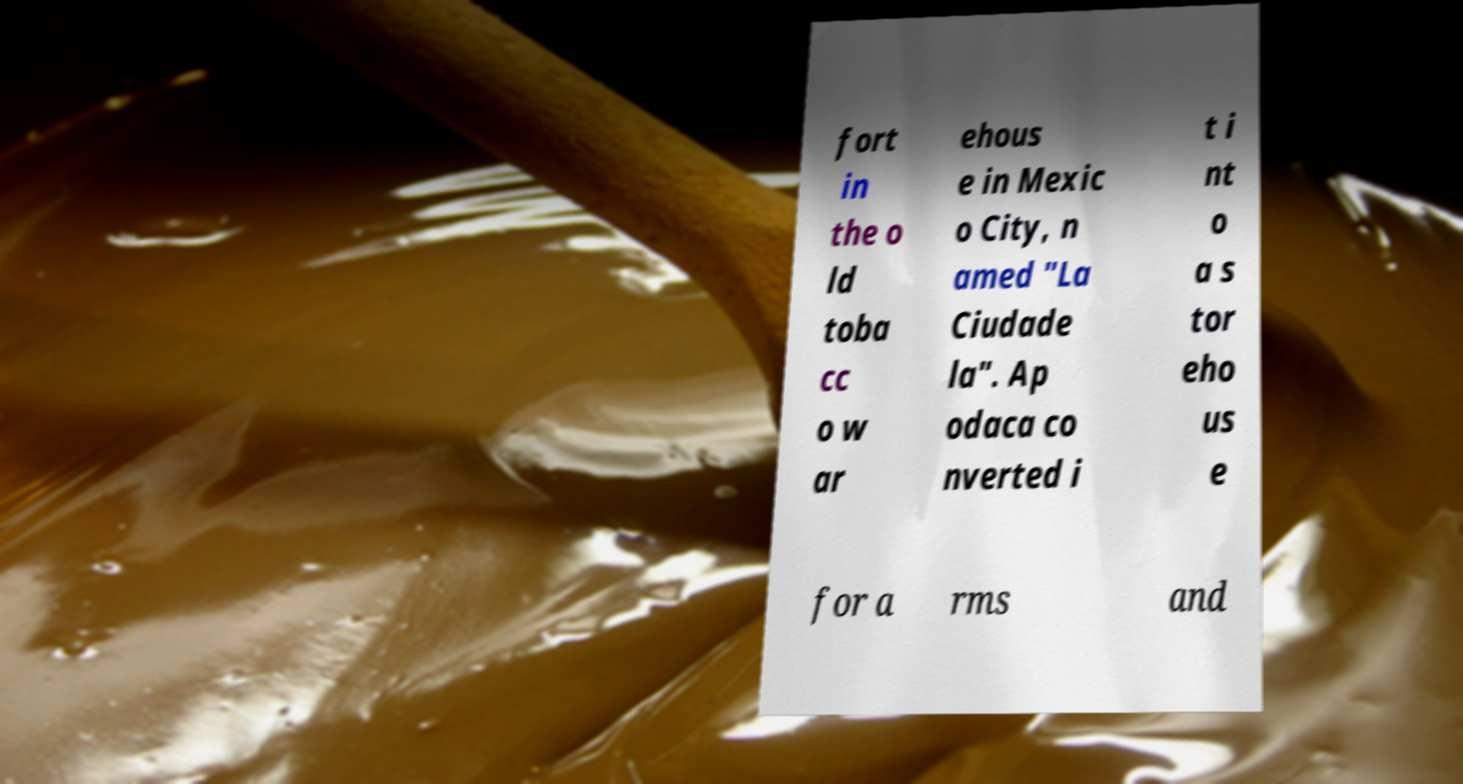For documentation purposes, I need the text within this image transcribed. Could you provide that? fort in the o ld toba cc o w ar ehous e in Mexic o City, n amed "La Ciudade la". Ap odaca co nverted i t i nt o a s tor eho us e for a rms and 